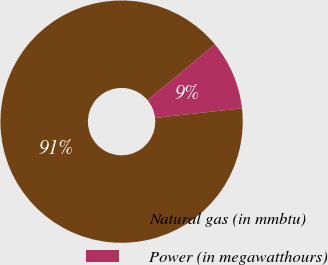Convert chart. <chart><loc_0><loc_0><loc_500><loc_500><pie_chart><fcel>Natural gas (in mmbtu)<fcel>Power (in megawatthours)<nl><fcel>90.76%<fcel>9.24%<nl></chart> 